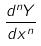Convert formula to latex. <formula><loc_0><loc_0><loc_500><loc_500>\frac { d ^ { n } Y } { d x ^ { n } }</formula> 